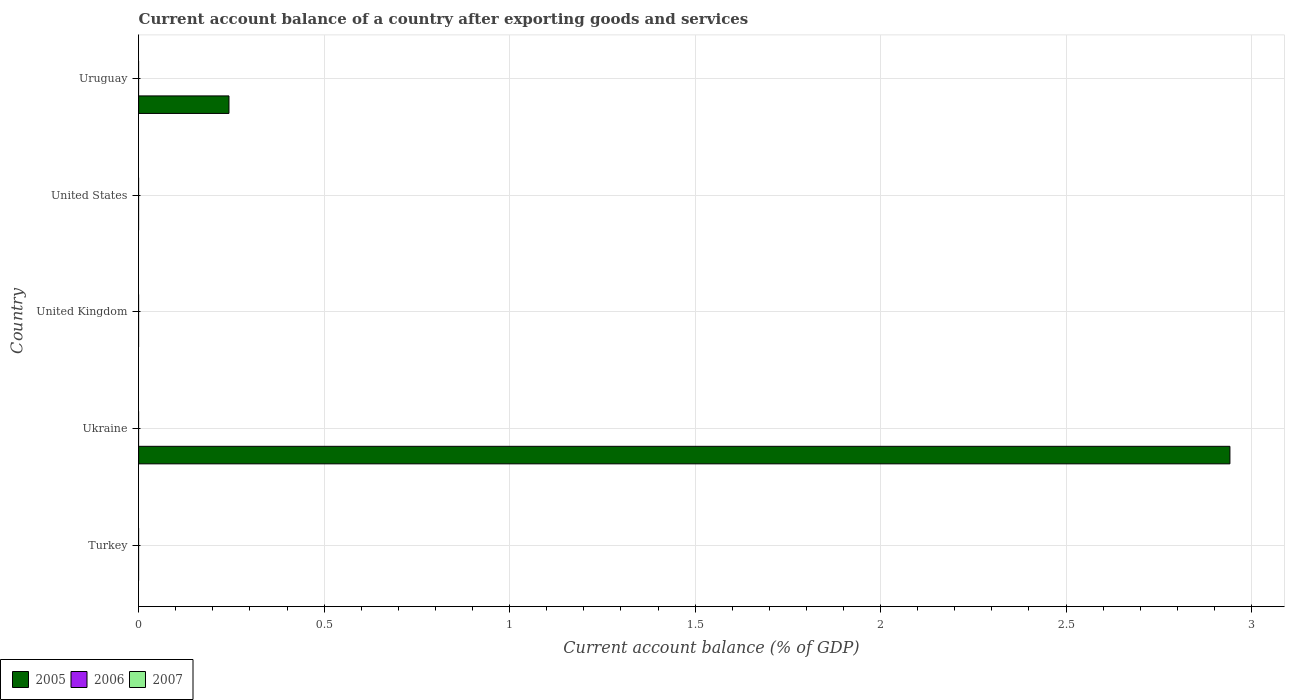How many different coloured bars are there?
Your answer should be very brief. 1. Are the number of bars per tick equal to the number of legend labels?
Keep it short and to the point. No. Are the number of bars on each tick of the Y-axis equal?
Provide a succinct answer. No. How many bars are there on the 2nd tick from the top?
Keep it short and to the point. 0. What is the label of the 4th group of bars from the top?
Keep it short and to the point. Ukraine. In how many cases, is the number of bars for a given country not equal to the number of legend labels?
Your answer should be compact. 5. Across all countries, what is the maximum account balance in 2005?
Provide a short and direct response. 2.94. Across all countries, what is the minimum account balance in 2007?
Your answer should be very brief. 0. In which country was the account balance in 2005 maximum?
Your answer should be very brief. Ukraine. What is the total account balance in 2007 in the graph?
Offer a terse response. 0. What is the difference between the account balance in 2005 in Ukraine and that in Uruguay?
Provide a succinct answer. 2.7. What is the difference between the account balance in 2005 in United States and the account balance in 2006 in Turkey?
Make the answer very short. 0. What is the average account balance in 2005 per country?
Offer a terse response. 0.64. What is the difference between the highest and the lowest account balance in 2005?
Make the answer very short. 2.94. Is it the case that in every country, the sum of the account balance in 2005 and account balance in 2007 is greater than the account balance in 2006?
Your answer should be compact. No. How many bars are there?
Ensure brevity in your answer.  2. What is the difference between two consecutive major ticks on the X-axis?
Provide a short and direct response. 0.5. Does the graph contain grids?
Give a very brief answer. Yes. Where does the legend appear in the graph?
Your answer should be compact. Bottom left. What is the title of the graph?
Give a very brief answer. Current account balance of a country after exporting goods and services. What is the label or title of the X-axis?
Ensure brevity in your answer.  Current account balance (% of GDP). What is the label or title of the Y-axis?
Provide a succinct answer. Country. What is the Current account balance (% of GDP) in 2005 in Turkey?
Ensure brevity in your answer.  0. What is the Current account balance (% of GDP) in 2005 in Ukraine?
Ensure brevity in your answer.  2.94. What is the Current account balance (% of GDP) in 2007 in Ukraine?
Give a very brief answer. 0. What is the Current account balance (% of GDP) in 2005 in United States?
Your answer should be very brief. 0. What is the Current account balance (% of GDP) in 2006 in United States?
Give a very brief answer. 0. What is the Current account balance (% of GDP) of 2005 in Uruguay?
Offer a terse response. 0.24. Across all countries, what is the maximum Current account balance (% of GDP) in 2005?
Your answer should be compact. 2.94. What is the total Current account balance (% of GDP) in 2005 in the graph?
Make the answer very short. 3.19. What is the difference between the Current account balance (% of GDP) in 2005 in Ukraine and that in Uruguay?
Provide a short and direct response. 2.7. What is the average Current account balance (% of GDP) in 2005 per country?
Give a very brief answer. 0.64. What is the average Current account balance (% of GDP) of 2006 per country?
Your answer should be very brief. 0. What is the ratio of the Current account balance (% of GDP) of 2005 in Ukraine to that in Uruguay?
Give a very brief answer. 12.08. What is the difference between the highest and the lowest Current account balance (% of GDP) in 2005?
Your answer should be compact. 2.94. 